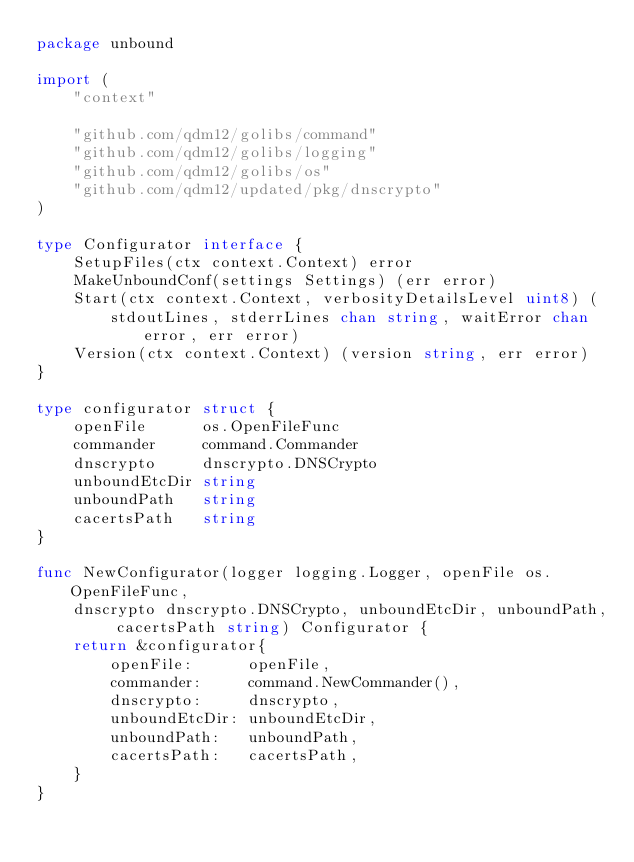Convert code to text. <code><loc_0><loc_0><loc_500><loc_500><_Go_>package unbound

import (
	"context"

	"github.com/qdm12/golibs/command"
	"github.com/qdm12/golibs/logging"
	"github.com/qdm12/golibs/os"
	"github.com/qdm12/updated/pkg/dnscrypto"
)

type Configurator interface {
	SetupFiles(ctx context.Context) error
	MakeUnboundConf(settings Settings) (err error)
	Start(ctx context.Context, verbosityDetailsLevel uint8) (
		stdoutLines, stderrLines chan string, waitError chan error, err error)
	Version(ctx context.Context) (version string, err error)
}

type configurator struct {
	openFile      os.OpenFileFunc
	commander     command.Commander
	dnscrypto     dnscrypto.DNSCrypto
	unboundEtcDir string
	unboundPath   string
	cacertsPath   string
}

func NewConfigurator(logger logging.Logger, openFile os.OpenFileFunc,
	dnscrypto dnscrypto.DNSCrypto, unboundEtcDir, unboundPath, cacertsPath string) Configurator {
	return &configurator{
		openFile:      openFile,
		commander:     command.NewCommander(),
		dnscrypto:     dnscrypto,
		unboundEtcDir: unboundEtcDir,
		unboundPath:   unboundPath,
		cacertsPath:   cacertsPath,
	}
}
</code> 